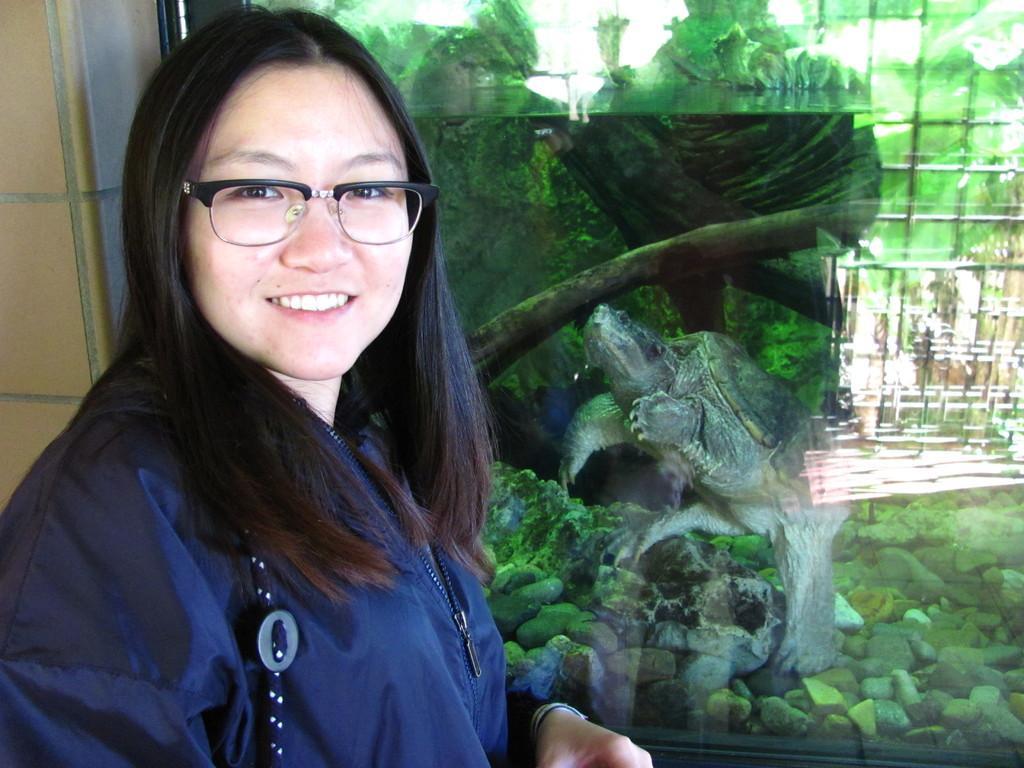Please provide a concise description of this image. In this image I can see a woman and I can see is wearing blue dress and specs. I can also see smile on her face. In the background I can see turtle and few stones. 